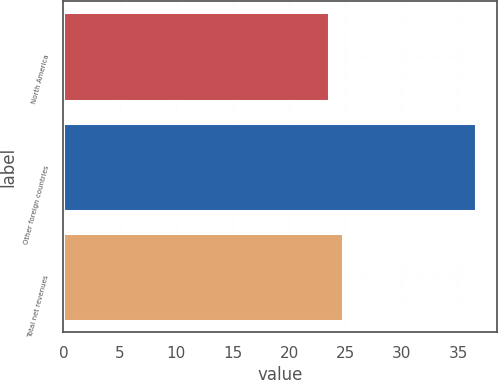Convert chart. <chart><loc_0><loc_0><loc_500><loc_500><bar_chart><fcel>North America<fcel>Other foreign countries<fcel>Total net revenues<nl><fcel>23.5<fcel>36.6<fcel>24.81<nl></chart> 